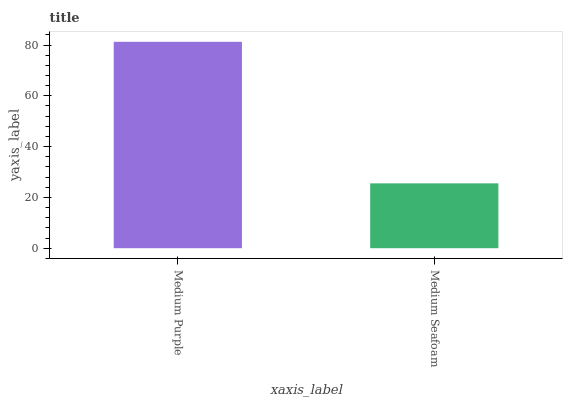Is Medium Seafoam the minimum?
Answer yes or no. Yes. Is Medium Purple the maximum?
Answer yes or no. Yes. Is Medium Seafoam the maximum?
Answer yes or no. No. Is Medium Purple greater than Medium Seafoam?
Answer yes or no. Yes. Is Medium Seafoam less than Medium Purple?
Answer yes or no. Yes. Is Medium Seafoam greater than Medium Purple?
Answer yes or no. No. Is Medium Purple less than Medium Seafoam?
Answer yes or no. No. Is Medium Purple the high median?
Answer yes or no. Yes. Is Medium Seafoam the low median?
Answer yes or no. Yes. Is Medium Seafoam the high median?
Answer yes or no. No. Is Medium Purple the low median?
Answer yes or no. No. 